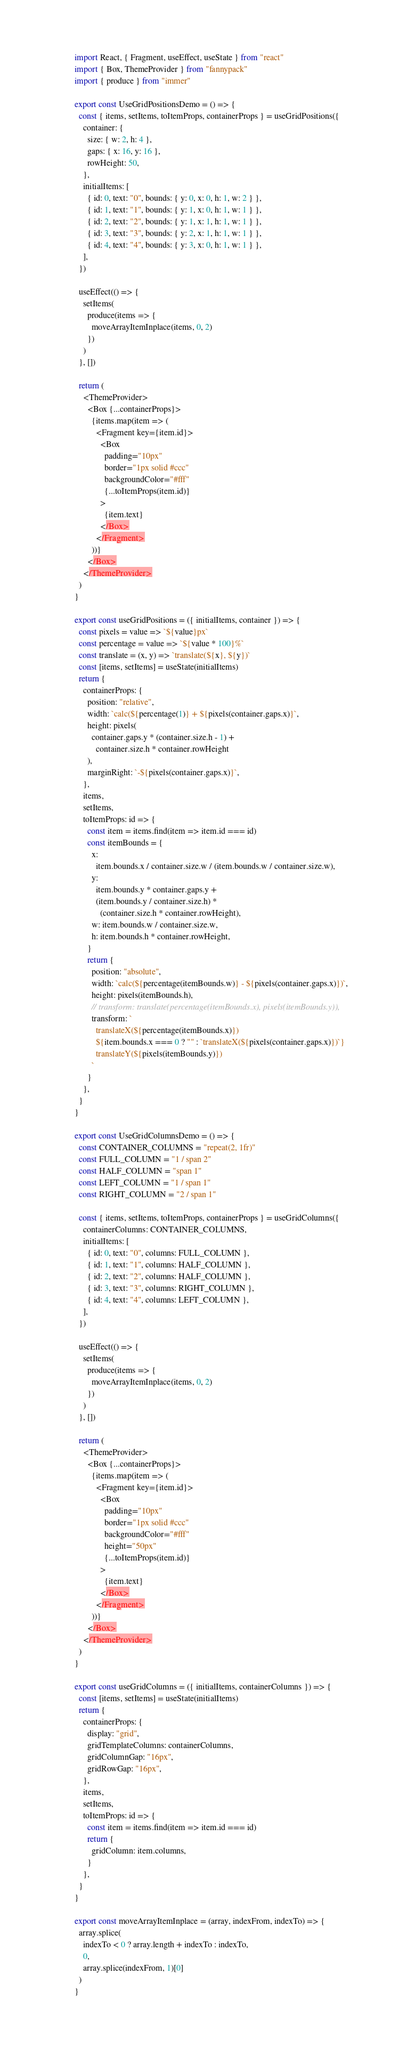Convert code to text. <code><loc_0><loc_0><loc_500><loc_500><_JavaScript_>import React, { Fragment, useEffect, useState } from "react"
import { Box, ThemeProvider } from "fannypack"
import { produce } from "immer"

export const UseGridPositionsDemo = () => {
  const { items, setItems, toItemProps, containerProps } = useGridPositions({
    container: {
      size: { w: 2, h: 4 },
      gaps: { x: 16, y: 16 },
      rowHeight: 50,
    },
    initialItems: [
      { id: 0, text: "0", bounds: { y: 0, x: 0, h: 1, w: 2 } },
      { id: 1, text: "1", bounds: { y: 1, x: 0, h: 1, w: 1 } },
      { id: 2, text: "2", bounds: { y: 1, x: 1, h: 1, w: 1 } },
      { id: 3, text: "3", bounds: { y: 2, x: 1, h: 1, w: 1 } },
      { id: 4, text: "4", bounds: { y: 3, x: 0, h: 1, w: 1 } },
    ],
  })

  useEffect(() => {
    setItems(
      produce(items => {
        moveArrayItemInplace(items, 0, 2)
      })
    )
  }, [])

  return (
    <ThemeProvider>
      <Box {...containerProps}>
        {items.map(item => (
          <Fragment key={item.id}>
            <Box
              padding="10px"
              border="1px solid #ccc"
              backgroundColor="#fff"
              {...toItemProps(item.id)}
            >
              {item.text}
            </Box>
          </Fragment>
        ))}
      </Box>
    </ThemeProvider>
  )
}

export const useGridPositions = ({ initialItems, container }) => {
  const pixels = value => `${value}px`
  const percentage = value => `${value * 100}%`
  const translate = (x, y) => `translate(${x}, ${y})`
  const [items, setItems] = useState(initialItems)
  return {
    containerProps: {
      position: "relative",
      width: `calc(${percentage(1)} + ${pixels(container.gaps.x)}`,
      height: pixels(
        container.gaps.y * (container.size.h - 1) +
          container.size.h * container.rowHeight
      ),
      marginRight: `-${pixels(container.gaps.x)}`,
    },
    items,
    setItems,
    toItemProps: id => {
      const item = items.find(item => item.id === id)
      const itemBounds = {
        x:
          item.bounds.x / container.size.w / (item.bounds.w / container.size.w),
        y:
          item.bounds.y * container.gaps.y +
          (item.bounds.y / container.size.h) *
            (container.size.h * container.rowHeight),
        w: item.bounds.w / container.size.w,
        h: item.bounds.h * container.rowHeight,
      }
      return {
        position: "absolute",
        width: `calc(${percentage(itemBounds.w)} - ${pixels(container.gaps.x)})`,
        height: pixels(itemBounds.h),
        // transform: translate(percentage(itemBounds.x), pixels(itemBounds.y)),
        transform: `
          translateX(${percentage(itemBounds.x)})
          ${item.bounds.x === 0 ? "" : `translateX(${pixels(container.gaps.x)})`}
          translateY(${pixels(itemBounds.y)})
        `
      }
    },
  }
}

export const UseGridColumnsDemo = () => {
  const CONTAINER_COLUMNS = "repeat(2, 1fr)"
  const FULL_COLUMN = "1 / span 2"
  const HALF_COLUMN = "span 1"
  const LEFT_COLUMN = "1 / span 1"
  const RIGHT_COLUMN = "2 / span 1"

  const { items, setItems, toItemProps, containerProps } = useGridColumns({
    containerColumns: CONTAINER_COLUMNS,
    initialItems: [
      { id: 0, text: "0", columns: FULL_COLUMN },
      { id: 1, text: "1", columns: HALF_COLUMN },
      { id: 2, text: "2", columns: HALF_COLUMN },
      { id: 3, text: "3", columns: RIGHT_COLUMN },
      { id: 4, text: "4", columns: LEFT_COLUMN },
    ],
  })

  useEffect(() => {
    setItems(
      produce(items => {
        moveArrayItemInplace(items, 0, 2)
      })
    )
  }, [])

  return (
    <ThemeProvider>
      <Box {...containerProps}>
        {items.map(item => (
          <Fragment key={item.id}>
            <Box
              padding="10px"
              border="1px solid #ccc"
              backgroundColor="#fff"
              height="50px"
              {...toItemProps(item.id)}
            >
              {item.text}
            </Box>
          </Fragment>
        ))}
      </Box>
    </ThemeProvider>
  )
}

export const useGridColumns = ({ initialItems, containerColumns }) => {
  const [items, setItems] = useState(initialItems)
  return {
    containerProps: {
      display: "grid",
      gridTemplateColumns: containerColumns,
      gridColumnGap: "16px",
      gridRowGap: "16px",
    },
    items,
    setItems,
    toItemProps: id => {
      const item = items.find(item => item.id === id)
      return {
        gridColumn: item.columns,
      }
    },
  }
}

export const moveArrayItemInplace = (array, indexFrom, indexTo) => {
  array.splice(
    indexTo < 0 ? array.length + indexTo : indexTo,
    0,
    array.splice(indexFrom, 1)[0]
  )
}
</code> 